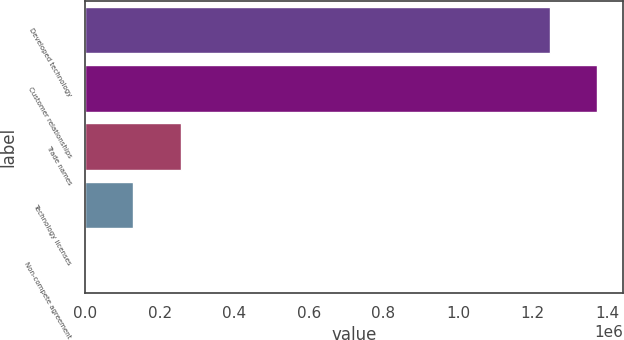Convert chart. <chart><loc_0><loc_0><loc_500><loc_500><bar_chart><fcel>Developed technology<fcel>Customer relationships<fcel>Trade names<fcel>Technology licenses<fcel>Non-compete agreement<nl><fcel>1.24634e+06<fcel>1.3735e+06<fcel>255366<fcel>128196<fcel>1026<nl></chart> 